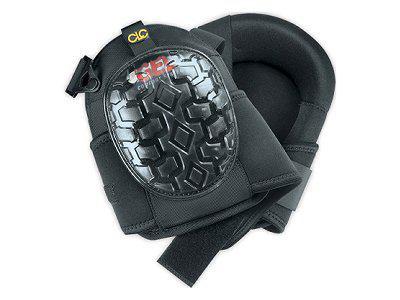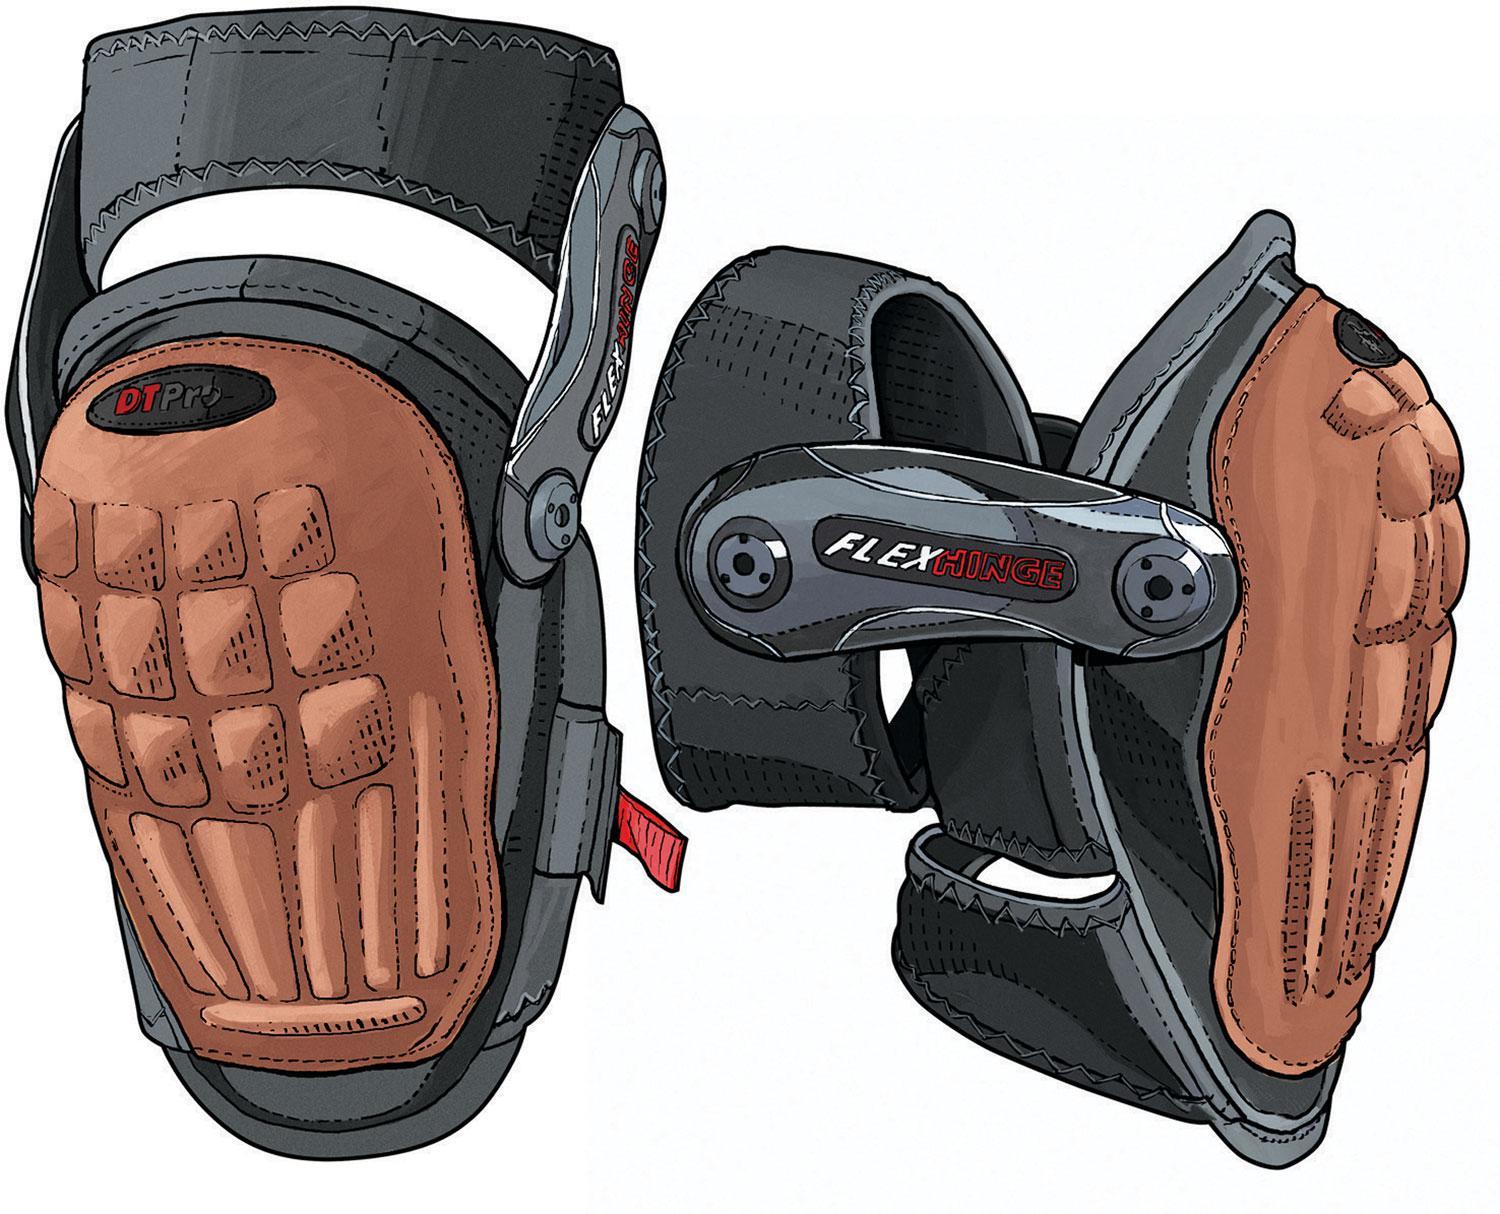The first image is the image on the left, the second image is the image on the right. Assess this claim about the two images: "An image shows a pair of black knee pads with yellow trim on the front.". Correct or not? Answer yes or no. No. The first image is the image on the left, the second image is the image on the right. Assess this claim about the two images: "At least one of the sets of knee pads is only yellow and grey.". Correct or not? Answer yes or no. No. 